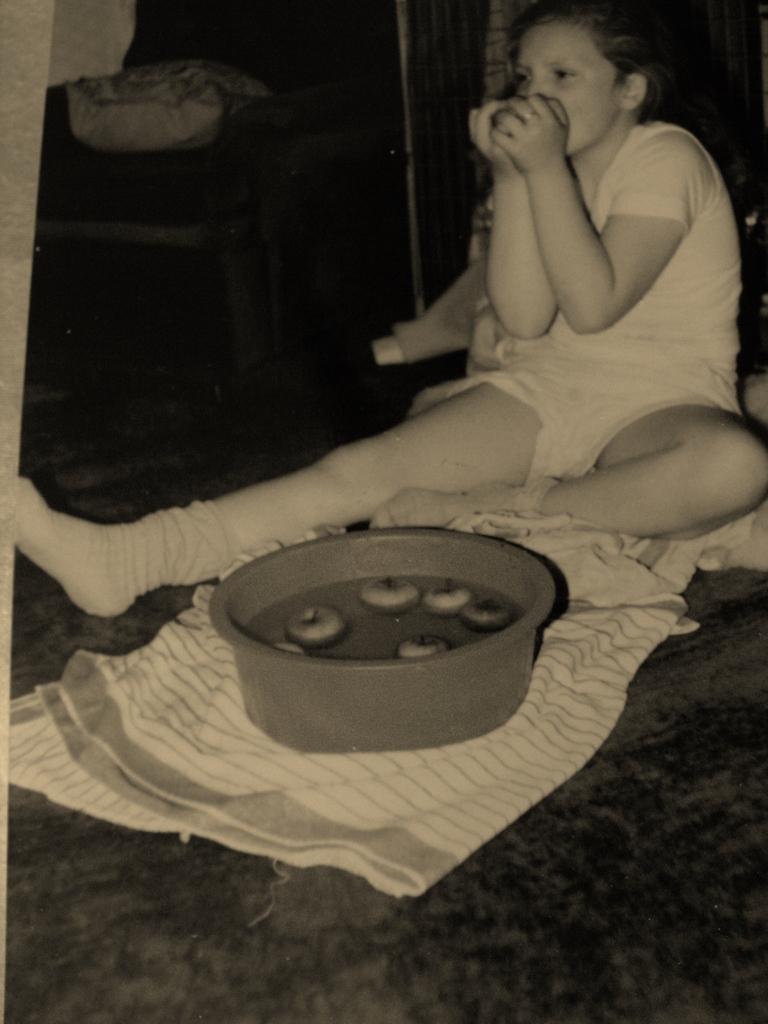How would you summarize this image in a sentence or two? In this image we can see a lady sitting and holding an object. We can also see a food item in the wooden object and it is placed on the cloth. 